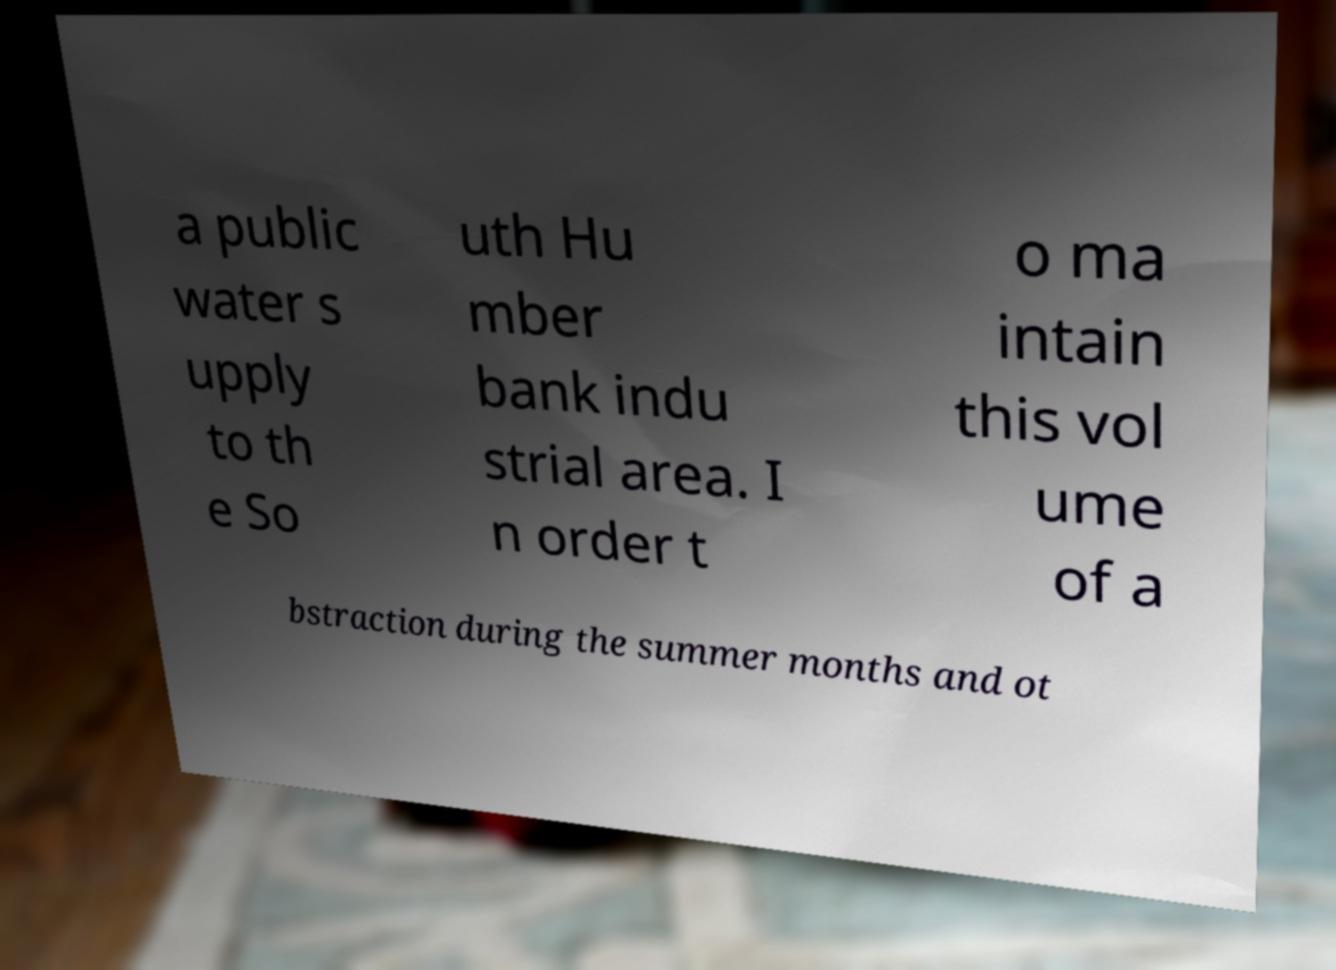Please identify and transcribe the text found in this image. a public water s upply to th e So uth Hu mber bank indu strial area. I n order t o ma intain this vol ume of a bstraction during the summer months and ot 